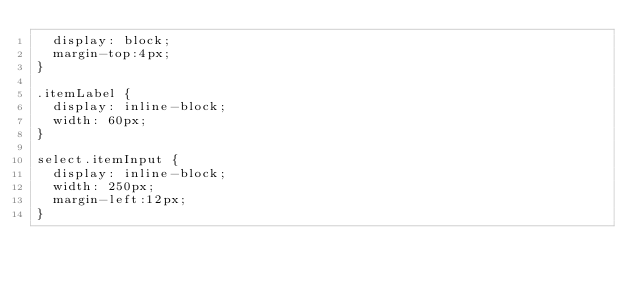Convert code to text. <code><loc_0><loc_0><loc_500><loc_500><_CSS_>  display: block;
  margin-top:4px;
}

.itemLabel {
  display: inline-block;
  width: 60px;
}

select.itemInput {
  display: inline-block;
  width: 250px;
  margin-left:12px;
}
</code> 